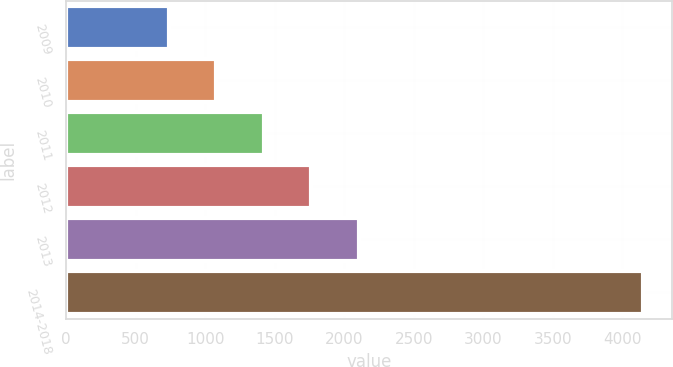Convert chart. <chart><loc_0><loc_0><loc_500><loc_500><bar_chart><fcel>2009<fcel>2010<fcel>2011<fcel>2012<fcel>2013<fcel>2014-2018<nl><fcel>740<fcel>1080.8<fcel>1421.6<fcel>1762.4<fcel>2103.2<fcel>4148<nl></chart> 